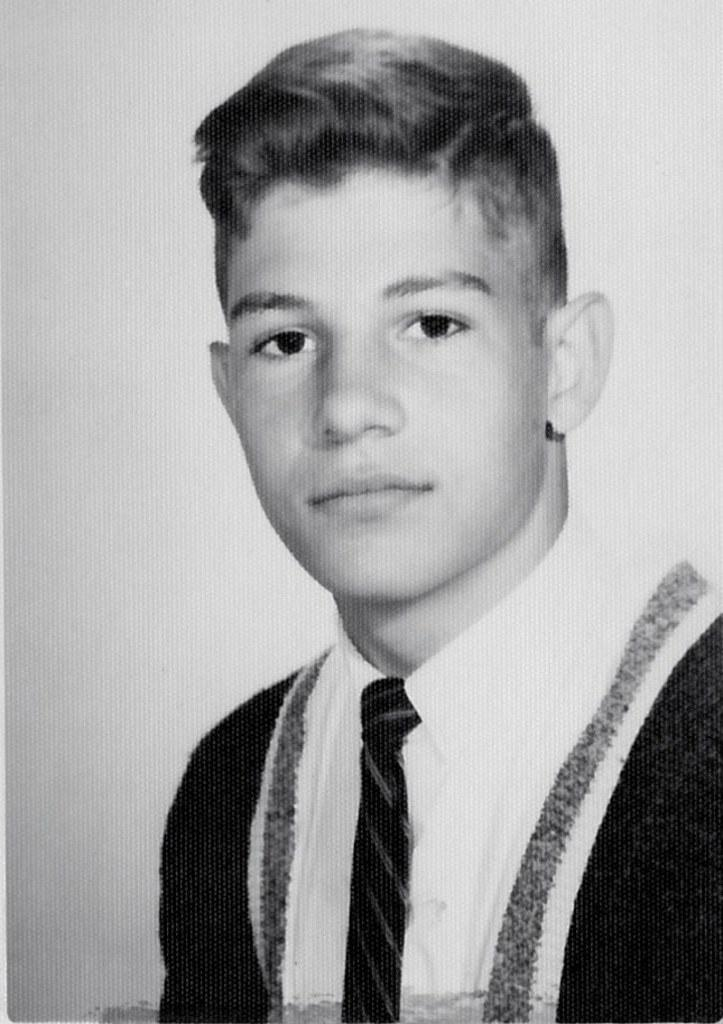What is the color scheme of the image? The image is black and white. Who is present in the image? There is a boy in the image. What is the boy wearing around his neck? The boy is wearing a tie. What type of clothing is the boy wearing? The boy is wearing a suit. What type of music can be heard playing in the background of the image? There is no music present in the image, as it is a still photograph. 